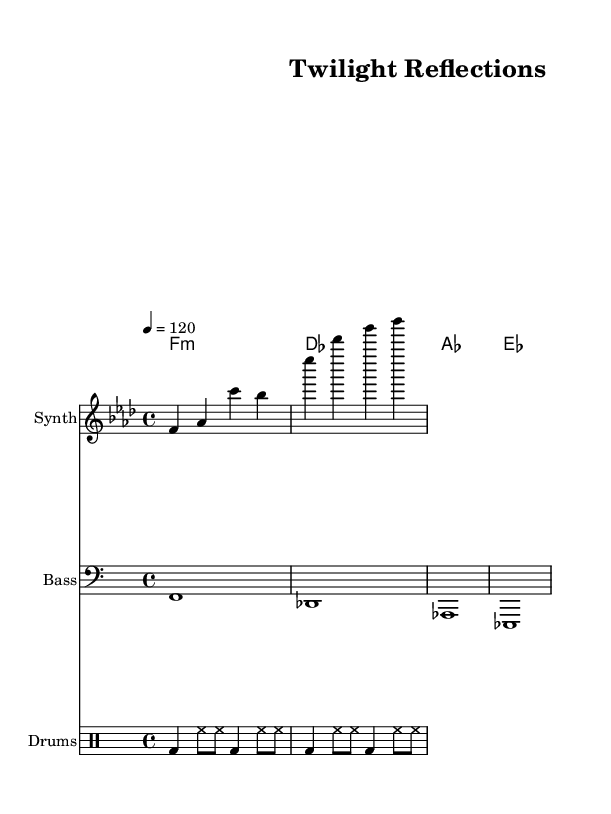What is the key signature of this music? The key signature is F minor, as indicated by the presence of four flats, which are B♭, E♭, A♭, and D♭. The first measure identifies this with the 'f' note under the key signature.
Answer: F minor What is the time signature of this piece? The time signature displayed at the beginning is 4/4, which means there are four beats in each measure and a quarter note receives one beat. This is noted directly in the score.
Answer: 4/4 What is the tempo marking for this piece? The tempo marking indicates a speed of 120 beats per minute, denoted by the instruction "4 = 120." This is usually placed above the staff at the start of the piece.
Answer: 120 How many distinct instrument parts are present in the score? The score contains four distinct instrument parts: Synth, Bass, Chord Names, and Drums. Each of these is labeled clearly in the score with the section appropriately noted.
Answer: Four What type of chords are used in the harmonies section? The harmonies are in a minor structure, specifically using F minor, D♭ major, A♭ major, and E♭ major chords, reflected through the chord symbols present in the score's chord section.
Answer: Minor What is the rhythm pattern for the drums? The rhythmic pattern consists of a bass drum and hi-hat with alternating eighth and quarter notes as detailed in the drum staff; this can be discerned by observing the placement of the notes in the drummode section.
Answer: Alternating How does the melody primarily move through the piece? The melody primarily moves within a range that stays close to the F minor scale, reflecting the tonal center of the piece and making melodic choices on the F, A♭, and C, consistent with the chords utilized.
Answer: Within F minor 